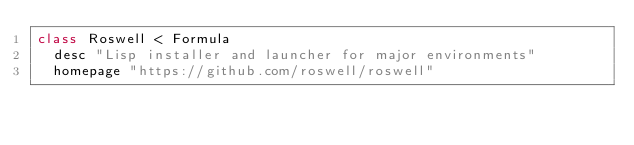<code> <loc_0><loc_0><loc_500><loc_500><_Ruby_>class Roswell < Formula
  desc "Lisp installer and launcher for major environments"
  homepage "https://github.com/roswell/roswell"</code> 